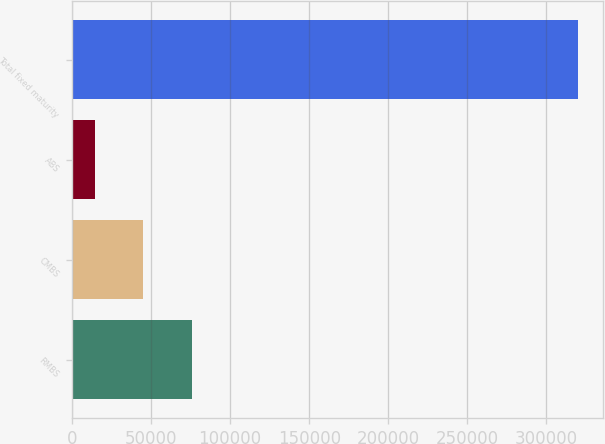<chart> <loc_0><loc_0><loc_500><loc_500><bar_chart><fcel>RMBS<fcel>CMBS<fcel>ABS<fcel>Total fixed maturity<nl><fcel>75781.6<fcel>45253.3<fcel>14725<fcel>320008<nl></chart> 